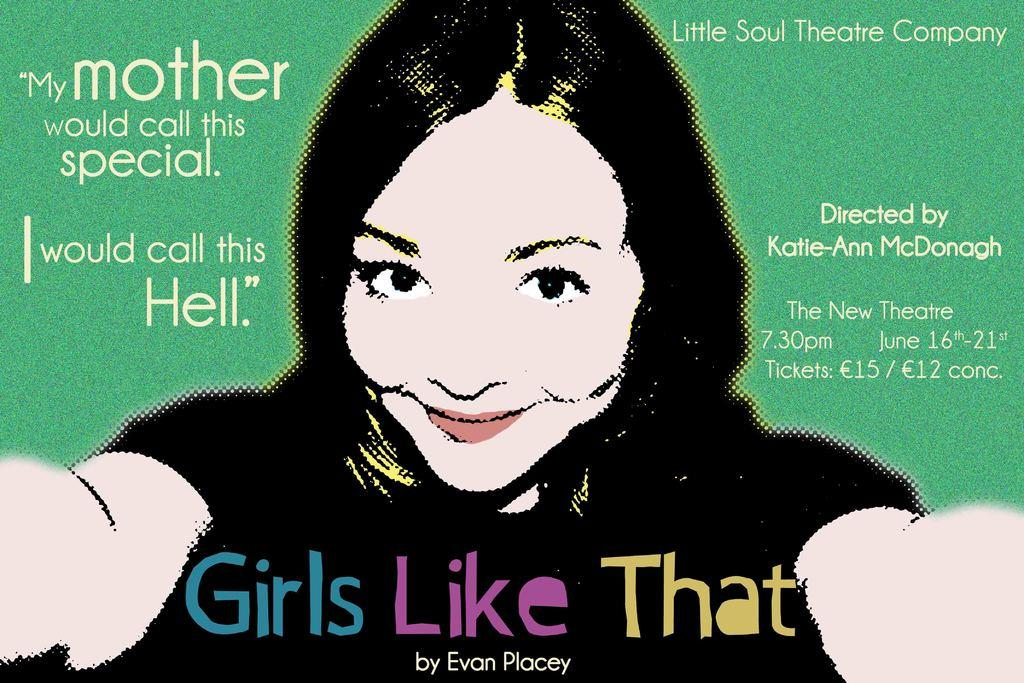What is present in the image that features a person? There is a poster in the image, and it features a woman. What is the woman doing in the poster? The woman is smiling in the poster. What else can be seen in the image besides the woman? There is text in the image. How many boys are sitting comfortably on the wealth displayed in the image? There are no boys, comfort, or wealth present in the image; it features a smiling woman on a poster with accompanying text. 